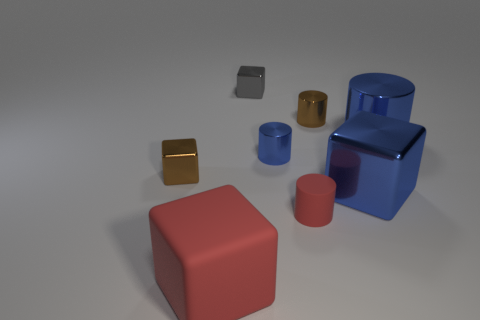Is the big cylinder the same color as the large shiny block?
Ensure brevity in your answer.  Yes. There is a rubber block that is in front of the large metallic cylinder; is it the same color as the small matte thing?
Make the answer very short. Yes. What number of big shiny things are the same color as the large cylinder?
Offer a very short reply. 1. Is the color of the thing that is in front of the red matte cylinder the same as the small object in front of the small brown cube?
Keep it short and to the point. Yes. What number of other things are the same size as the matte cylinder?
Make the answer very short. 4. What number of blue metallic objects are both to the right of the small brown cylinder and behind the blue cube?
Give a very brief answer. 1. Is the material of the small block behind the small blue metal cylinder the same as the small red object?
Give a very brief answer. No. What shape is the small brown thing that is behind the large thing to the right of the shiny thing in front of the brown block?
Your response must be concise. Cylinder. Are there the same number of brown metallic cylinders in front of the rubber cylinder and big shiny cubes that are in front of the gray object?
Offer a terse response. No. What is the color of the matte cylinder that is the same size as the gray cube?
Your response must be concise. Red. 